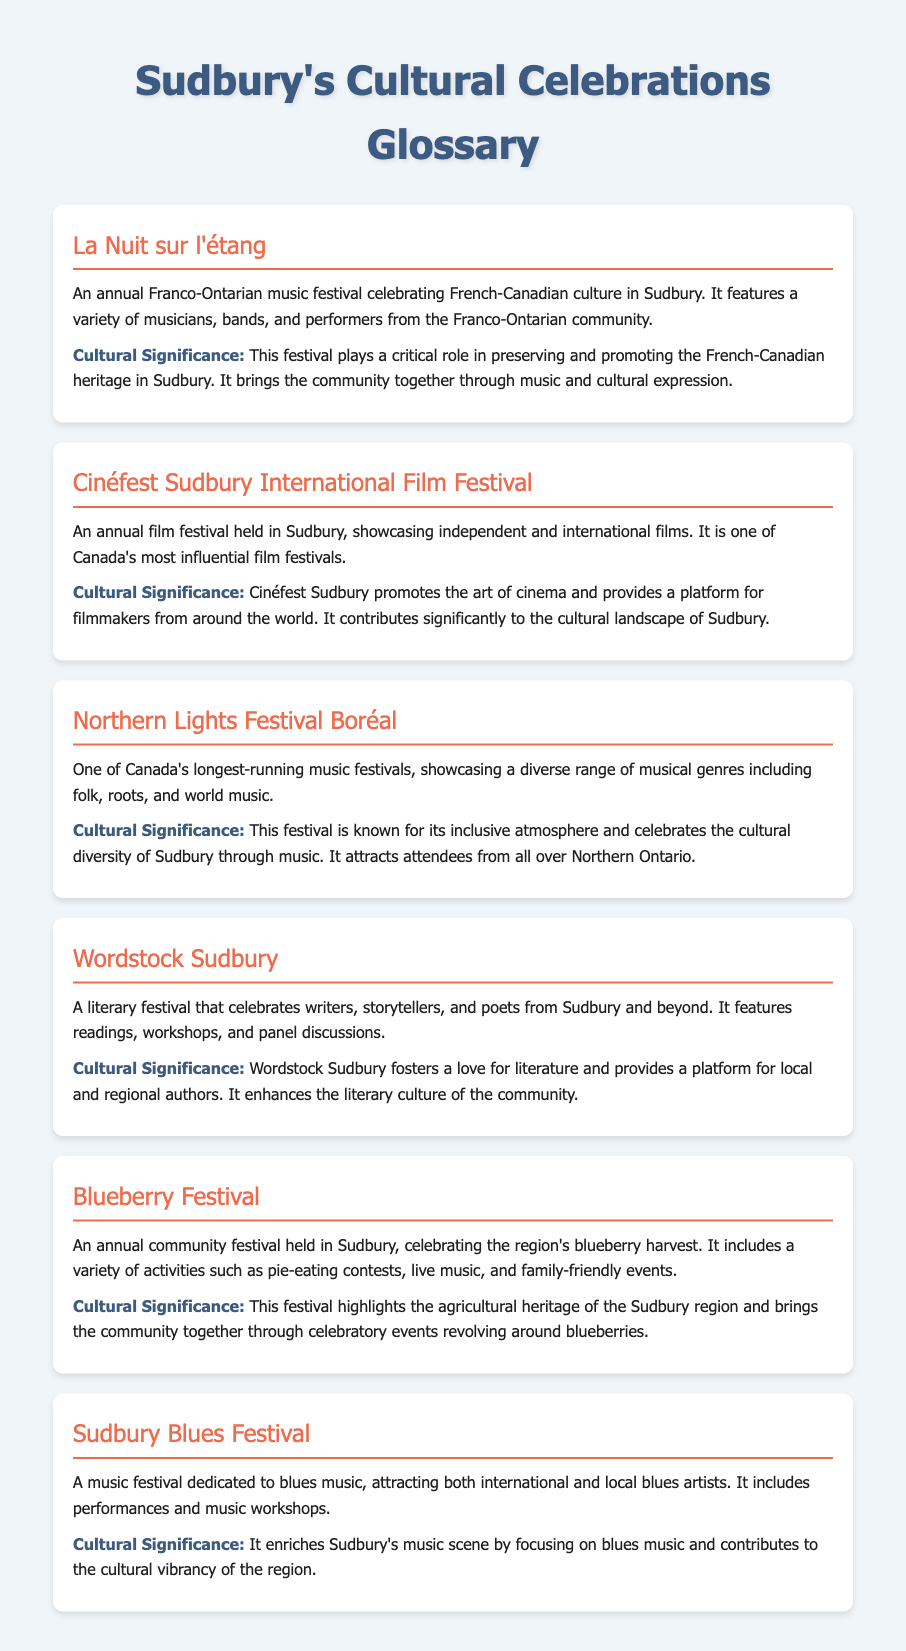What is the name of the festival celebrating French-Canadian culture? The festival specifically celebrating French-Canadian culture is named La Nuit sur l'étang.
Answer: La Nuit sur l'étang How often is the Cinéfest Sudbury International Film Festival held? The festival is an annual event held each year.
Answer: Annual What types of music are featured at the Northern Lights Festival Boréal? The festival showcases a diverse range of musical genres including folk, roots, and world music.
Answer: Folk, roots, and world music What is the main focus of Wordstock Sudbury? The main focus of Wordstock Sudbury is celebrating writers, storytellers, and poets.
Answer: Writers, storytellers, and poets Which festival includes pie-eating contests? The festival that includes pie-eating contests is the Blueberry Festival.
Answer: Blueberry Festival What role does the Sudbury Blues Festival play in the local music scene? The festival enriches Sudbury's music scene by focusing on blues music.
Answer: Enriches Sudbury's music scene How many major festivals are mentioned in the document? The document lists six major festivals in total.
Answer: Six Which festival promotes agricultural heritage? The festival that highlights agricultural heritage is the Blueberry Festival.
Answer: Blueberry Festival What does the cultural significance of La Nuit sur l'étang emphasize? The cultural significance emphasizes preserving and promoting French-Canadian heritage.
Answer: Preserving and promoting French-Canadian heritage 